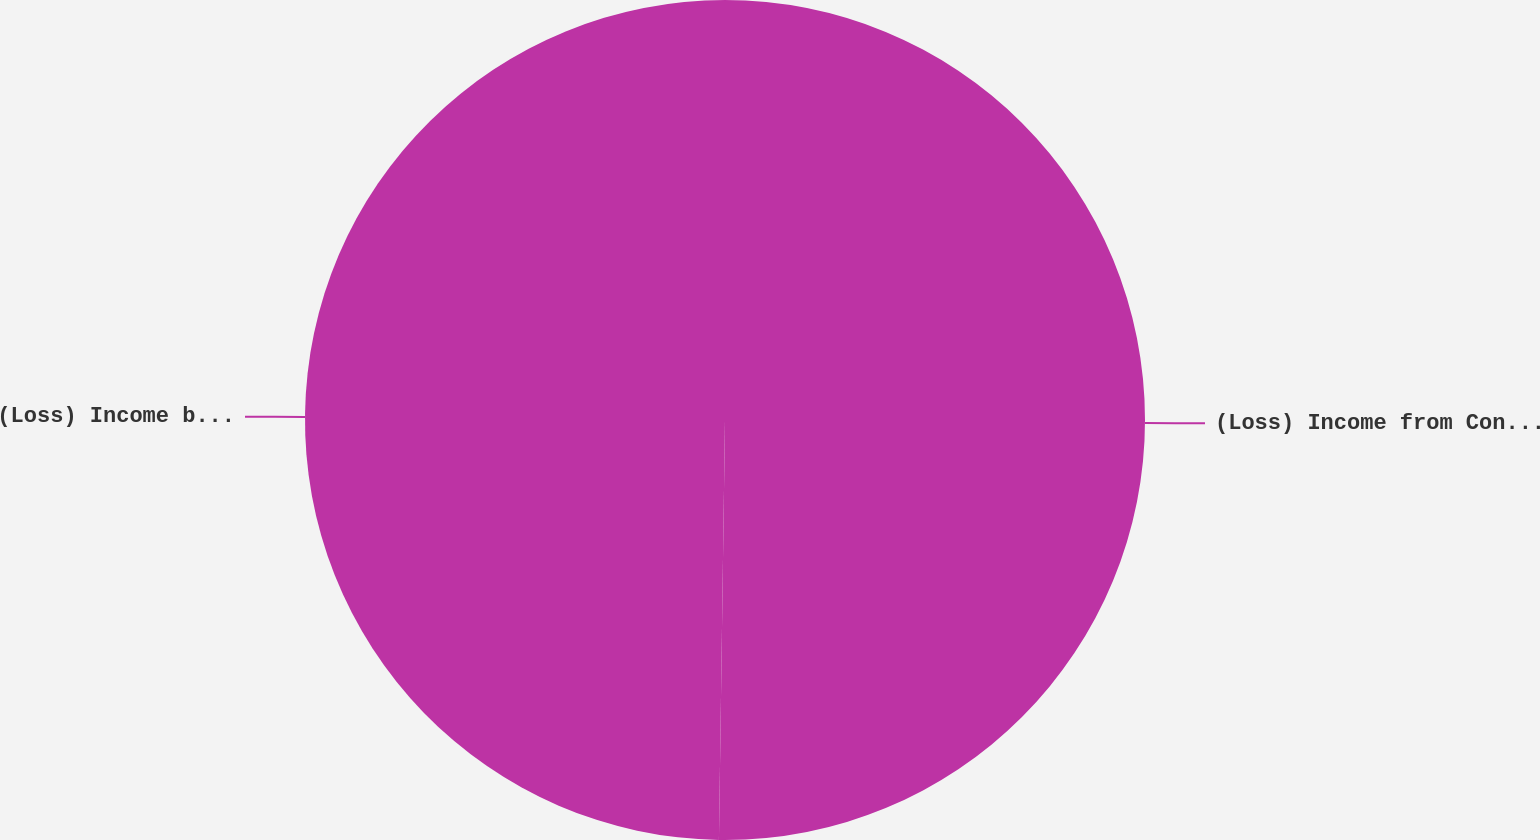<chart> <loc_0><loc_0><loc_500><loc_500><pie_chart><fcel>(Loss) Income from Continuing<fcel>(Loss) Income before<nl><fcel>50.23%<fcel>49.77%<nl></chart> 